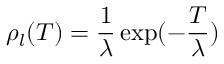<formula> <loc_0><loc_0><loc_500><loc_500>\rho _ { l } ( T ) = \frac { 1 } { \lambda } \exp ( - \frac { T } { \lambda } )</formula> 